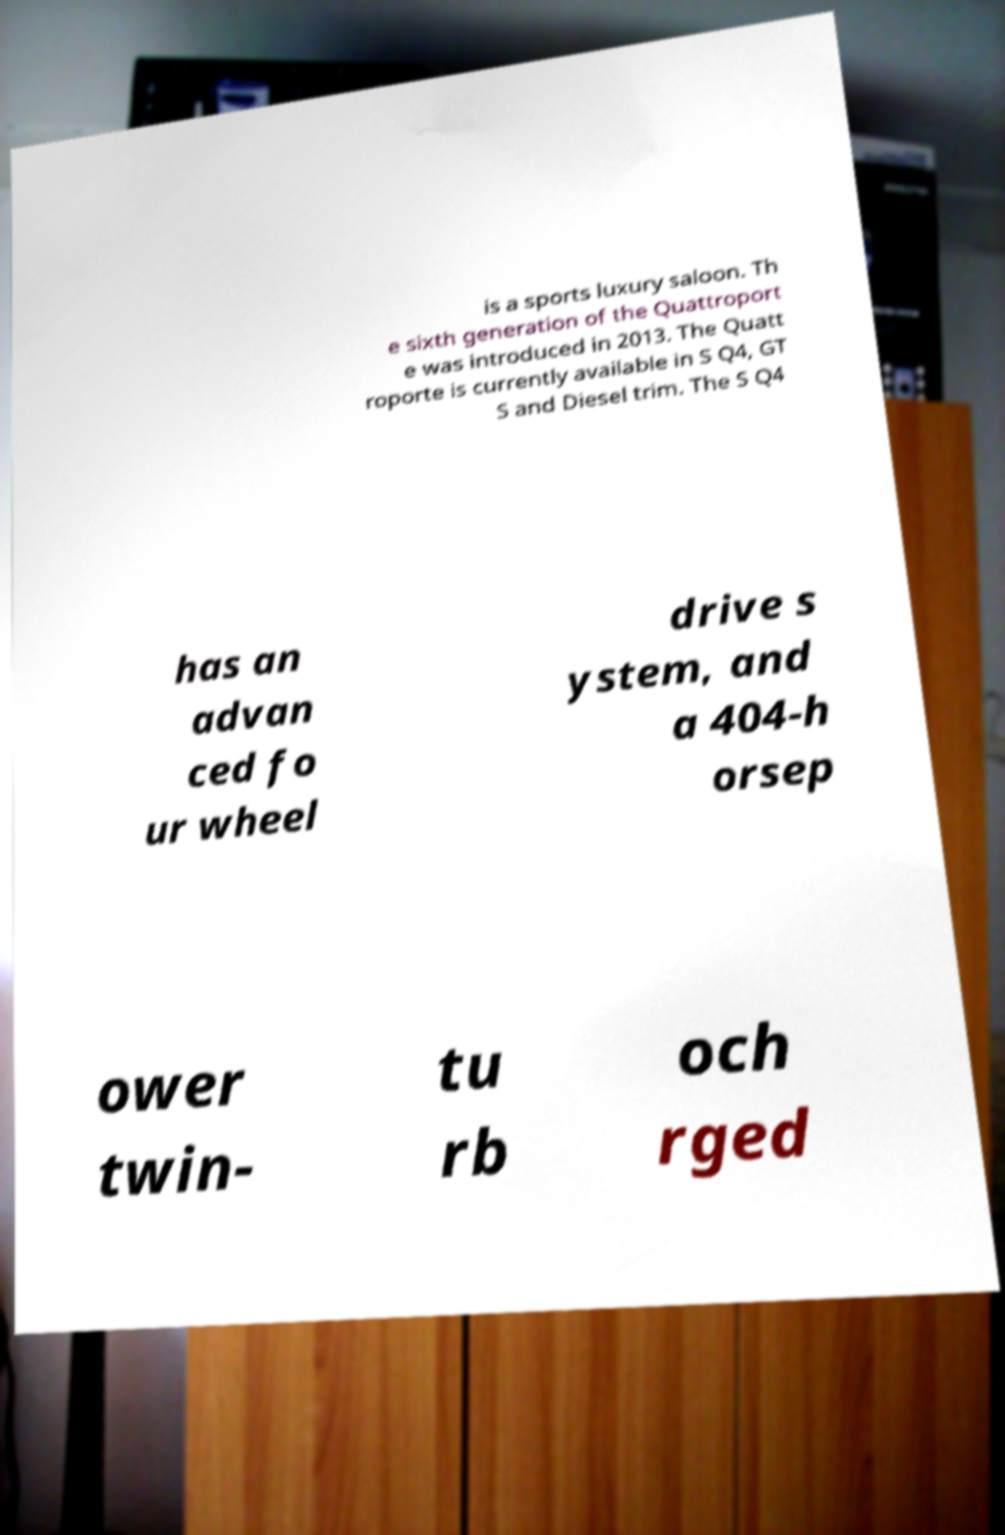Could you extract and type out the text from this image? is a sports luxury saloon. Th e sixth generation of the Quattroport e was introduced in 2013. The Quatt roporte is currently available in S Q4, GT S and Diesel trim. The S Q4 has an advan ced fo ur wheel drive s ystem, and a 404-h orsep ower twin- tu rb och rged 